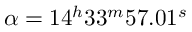Convert formula to latex. <formula><loc_0><loc_0><loc_500><loc_500>\alpha = 1 4 ^ { h } 3 3 ^ { m } 5 7 . 0 1 ^ { s }</formula> 